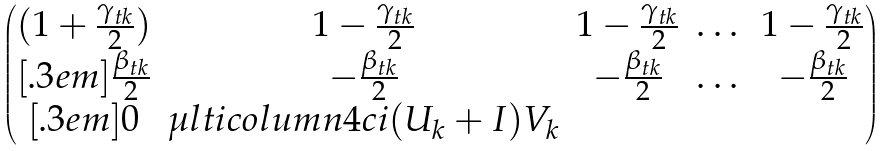Convert formula to latex. <formula><loc_0><loc_0><loc_500><loc_500>\begin{pmatrix} ( 1 + \frac { \gamma _ { t k } } { 2 } ) & 1 - \frac { \gamma _ { t k } } { 2 } & 1 - \frac { \gamma _ { t k } } { 2 } & \dots & 1 - \frac { \gamma _ { t k } } { 2 } \\ [ . 3 e m ] \frac { \beta _ { t k } } { 2 } & - \frac { \beta _ { t k } } { 2 } & - \frac { \beta _ { t k } } { 2 } & \dots & - \frac { \beta _ { t k } } { 2 } \\ [ . 3 e m ] 0 & \mu l t i c o l u m n { 4 } { c } { i ( U _ { k } + I ) V _ { k } } \end{pmatrix}</formula> 